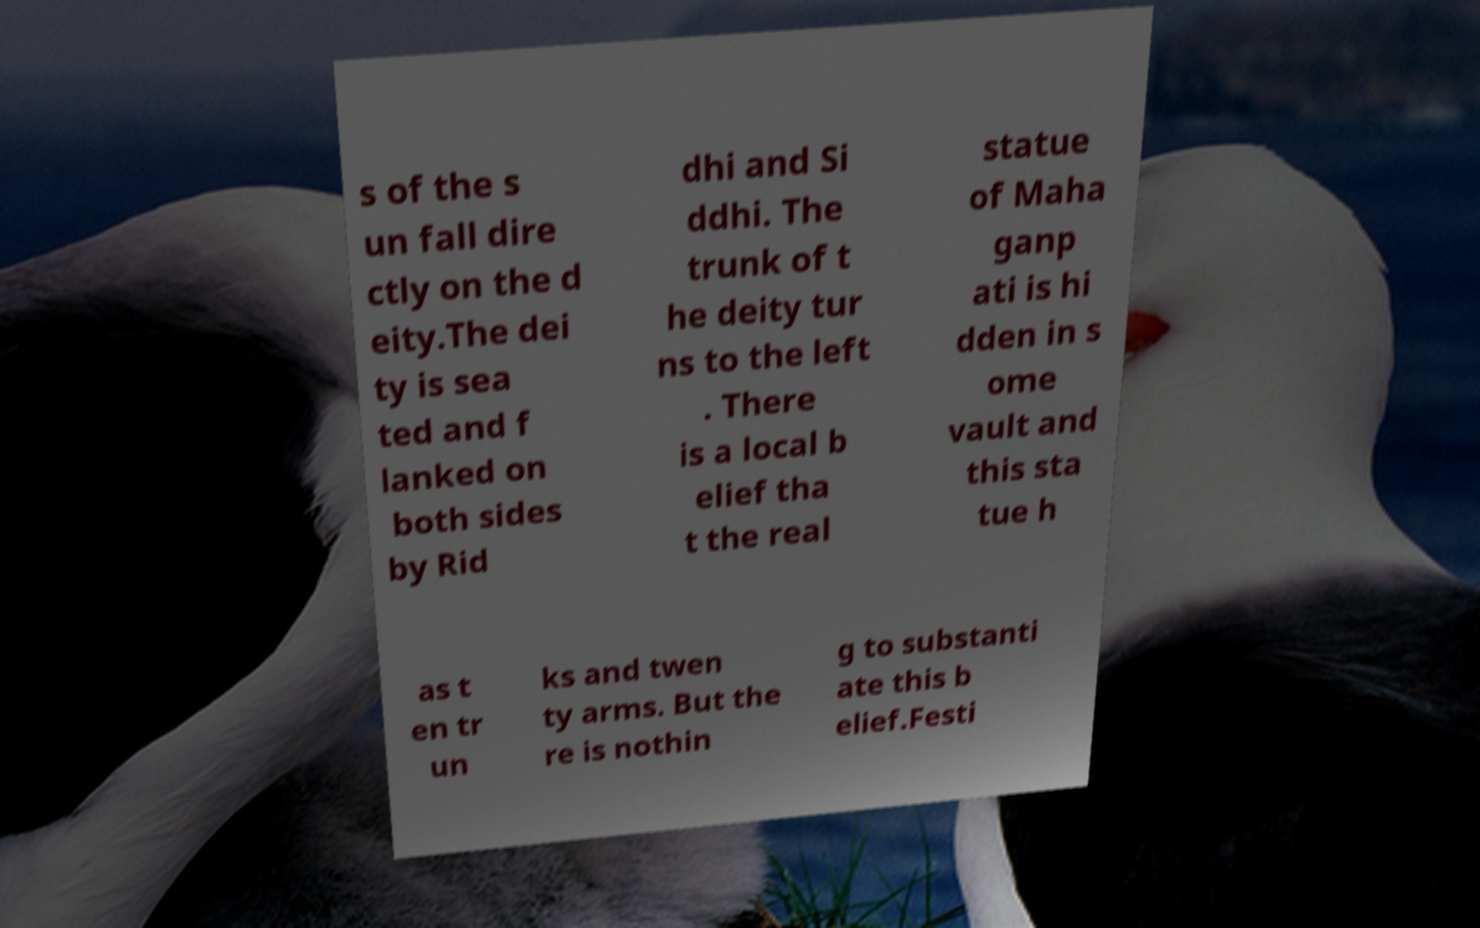Please identify and transcribe the text found in this image. s of the s un fall dire ctly on the d eity.The dei ty is sea ted and f lanked on both sides by Rid dhi and Si ddhi. The trunk of t he deity tur ns to the left . There is a local b elief tha t the real statue of Maha ganp ati is hi dden in s ome vault and this sta tue h as t en tr un ks and twen ty arms. But the re is nothin g to substanti ate this b elief.Festi 